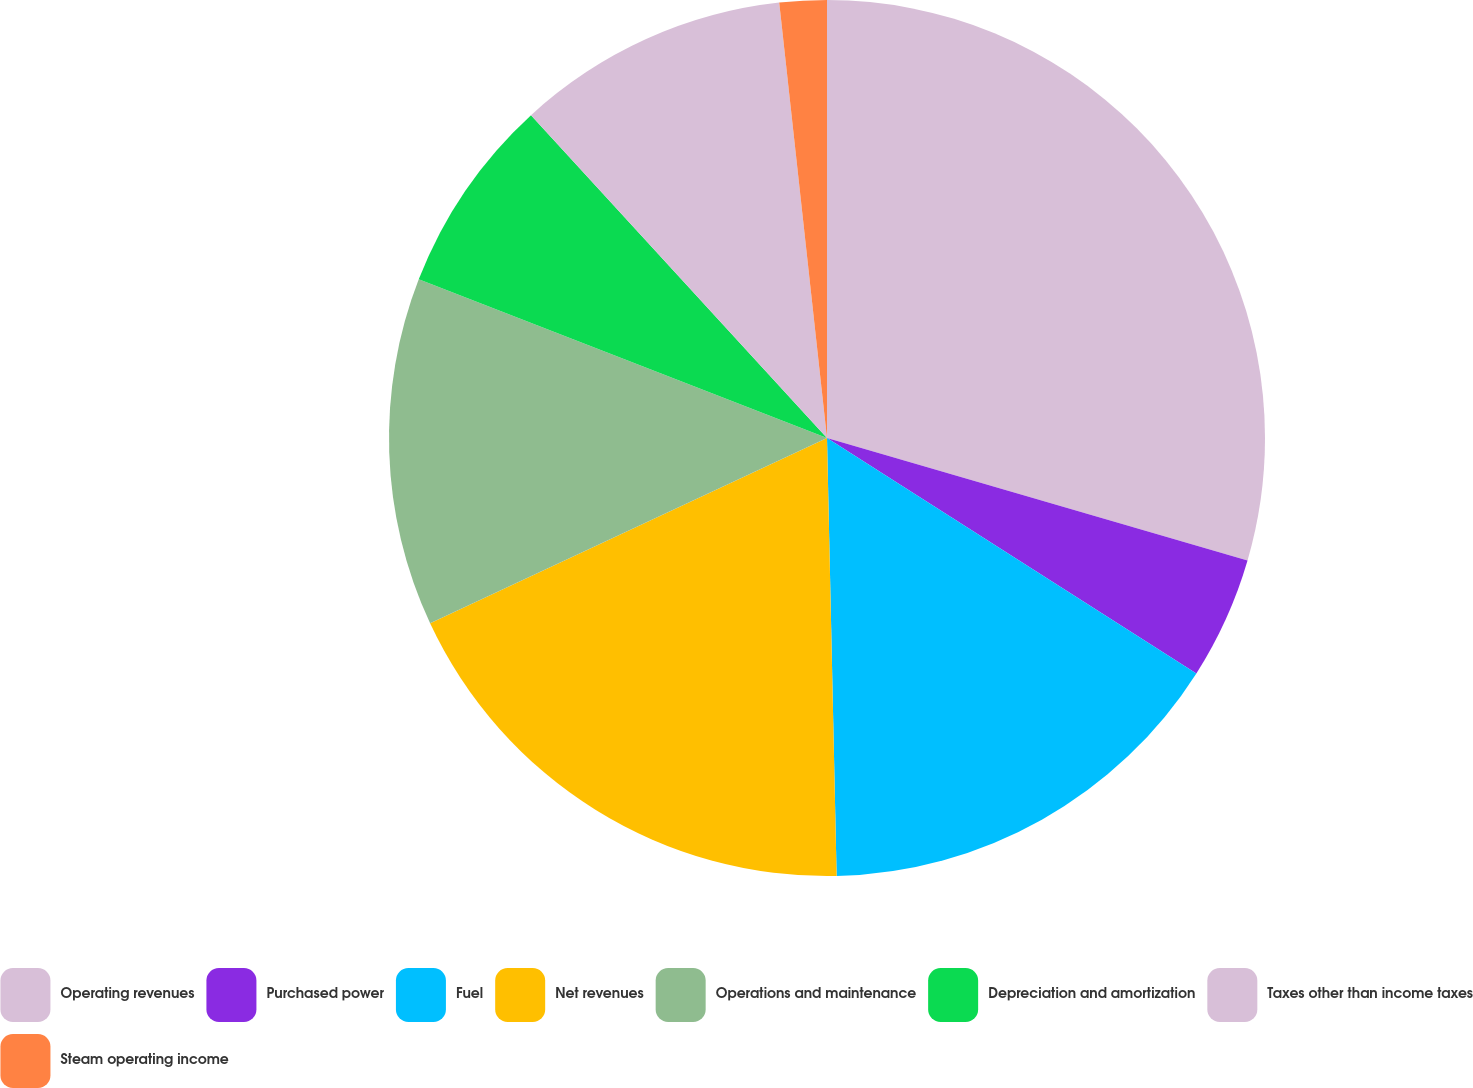Convert chart to OTSL. <chart><loc_0><loc_0><loc_500><loc_500><pie_chart><fcel>Operating revenues<fcel>Purchased power<fcel>Fuel<fcel>Net revenues<fcel>Operations and maintenance<fcel>Depreciation and amortization<fcel>Taxes other than income taxes<fcel>Steam operating income<nl><fcel>29.51%<fcel>4.52%<fcel>15.62%<fcel>18.4%<fcel>12.85%<fcel>7.29%<fcel>10.07%<fcel>1.74%<nl></chart> 